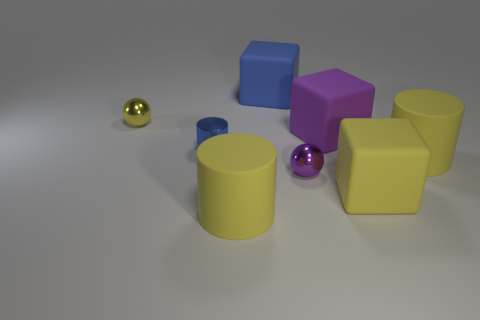Add 1 large red metallic blocks. How many objects exist? 9 Subtract all cylinders. How many objects are left? 5 Subtract all tiny yellow objects. Subtract all big yellow cubes. How many objects are left? 6 Add 6 big blue matte blocks. How many big blue matte blocks are left? 7 Add 4 blue cylinders. How many blue cylinders exist? 5 Subtract 1 yellow blocks. How many objects are left? 7 